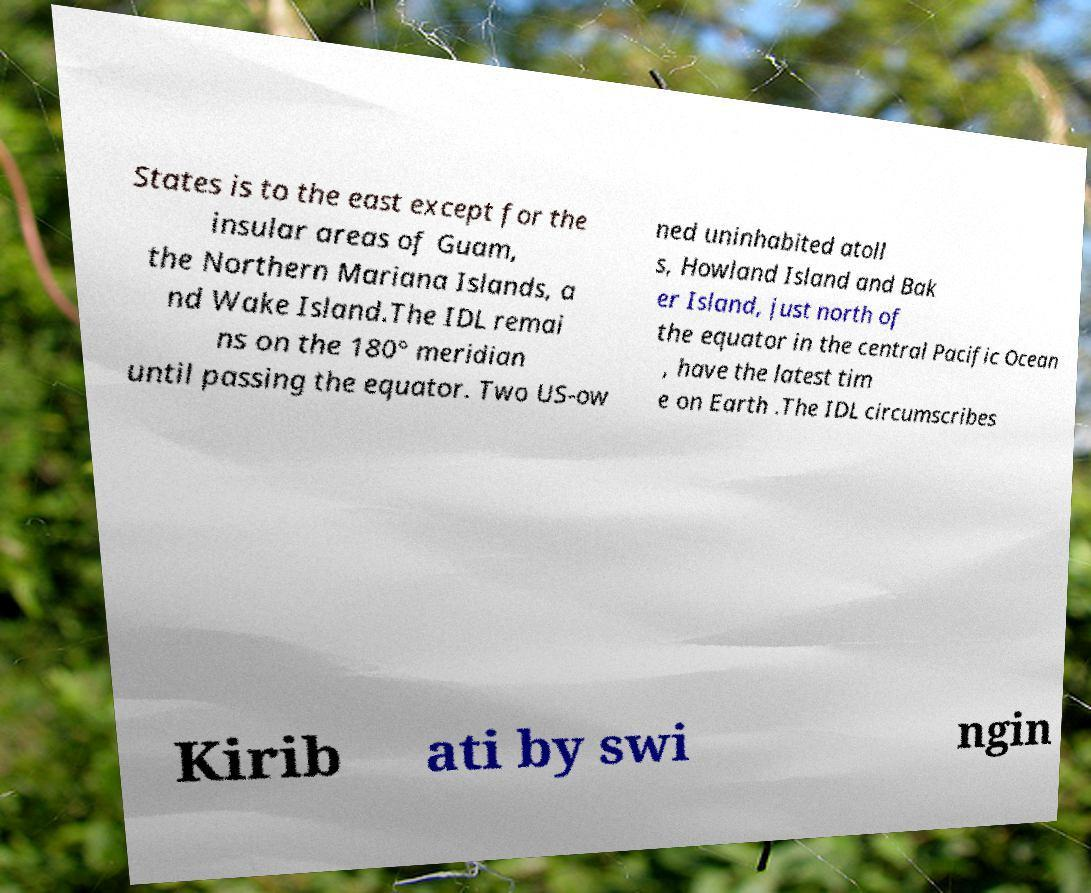Please read and relay the text visible in this image. What does it say? States is to the east except for the insular areas of Guam, the Northern Mariana Islands, a nd Wake Island.The IDL remai ns on the 180° meridian until passing the equator. Two US-ow ned uninhabited atoll s, Howland Island and Bak er Island, just north of the equator in the central Pacific Ocean , have the latest tim e on Earth .The IDL circumscribes Kirib ati by swi ngin 